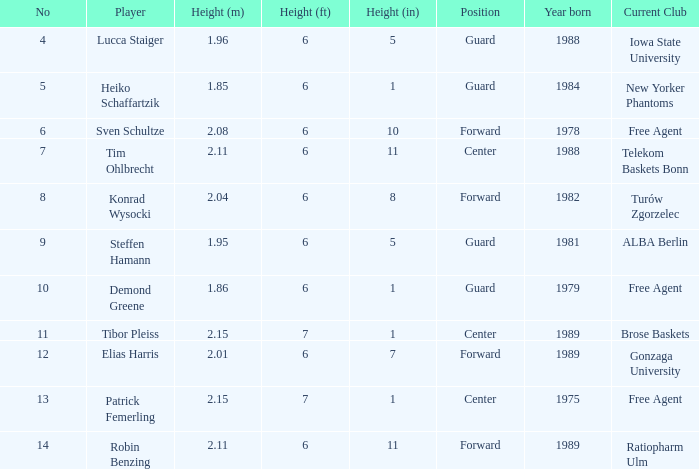Name the height for the player born in 1981 1.95. 